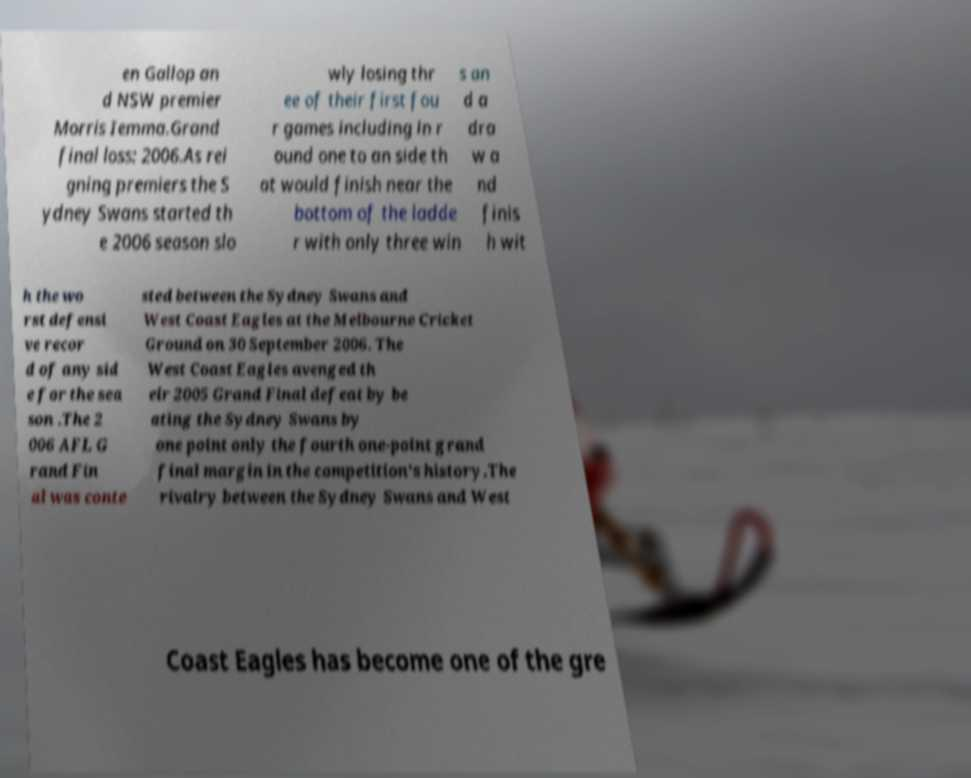For documentation purposes, I need the text within this image transcribed. Could you provide that? en Gallop an d NSW premier Morris Iemma.Grand final loss: 2006.As rei gning premiers the S ydney Swans started th e 2006 season slo wly losing thr ee of their first fou r games including in r ound one to an side th at would finish near the bottom of the ladde r with only three win s an d a dra w a nd finis h wit h the wo rst defensi ve recor d of any sid e for the sea son .The 2 006 AFL G rand Fin al was conte sted between the Sydney Swans and West Coast Eagles at the Melbourne Cricket Ground on 30 September 2006. The West Coast Eagles avenged th eir 2005 Grand Final defeat by be ating the Sydney Swans by one point only the fourth one-point grand final margin in the competition's history.The rivalry between the Sydney Swans and West Coast Eagles has become one of the gre 